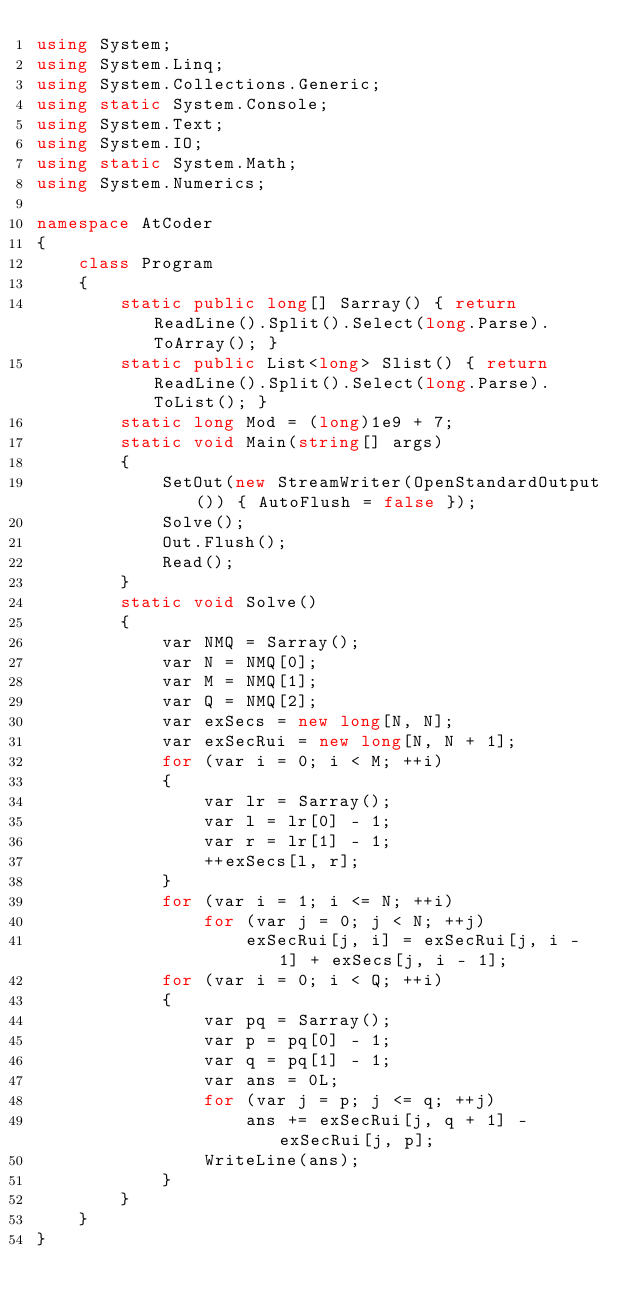<code> <loc_0><loc_0><loc_500><loc_500><_C#_>using System;
using System.Linq;
using System.Collections.Generic;
using static System.Console;
using System.Text;
using System.IO;
using static System.Math;
using System.Numerics;

namespace AtCoder
{
    class Program
    {
        static public long[] Sarray() { return ReadLine().Split().Select(long.Parse).ToArray(); }
        static public List<long> Slist() { return ReadLine().Split().Select(long.Parse).ToList(); }
        static long Mod = (long)1e9 + 7;
        static void Main(string[] args)
        {
            SetOut(new StreamWriter(OpenStandardOutput()) { AutoFlush = false });
            Solve();
            Out.Flush();
            Read();
        }
        static void Solve()
        {
            var NMQ = Sarray();
            var N = NMQ[0];
            var M = NMQ[1];
            var Q = NMQ[2];
            var exSecs = new long[N, N];
            var exSecRui = new long[N, N + 1];
            for (var i = 0; i < M; ++i)
            {
                var lr = Sarray();
                var l = lr[0] - 1;
                var r = lr[1] - 1;
                ++exSecs[l, r];
            }
            for (var i = 1; i <= N; ++i)
                for (var j = 0; j < N; ++j)
                    exSecRui[j, i] = exSecRui[j, i - 1] + exSecs[j, i - 1];
            for (var i = 0; i < Q; ++i)
            {
                var pq = Sarray();
                var p = pq[0] - 1;
                var q = pq[1] - 1;
                var ans = 0L;
                for (var j = p; j <= q; ++j)
                    ans += exSecRui[j, q + 1] - exSecRui[j, p];
                WriteLine(ans);
            }
        }
    }
}</code> 